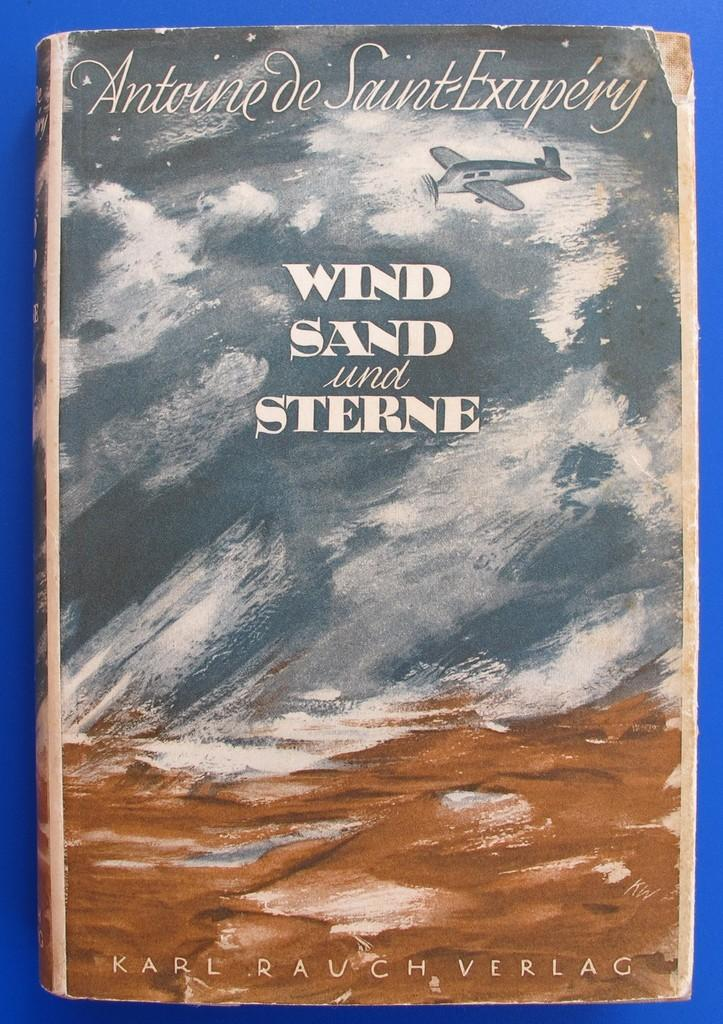<image>
Relay a brief, clear account of the picture shown. A book titled Wind Sand and Sterne is against a blue backdrop. 